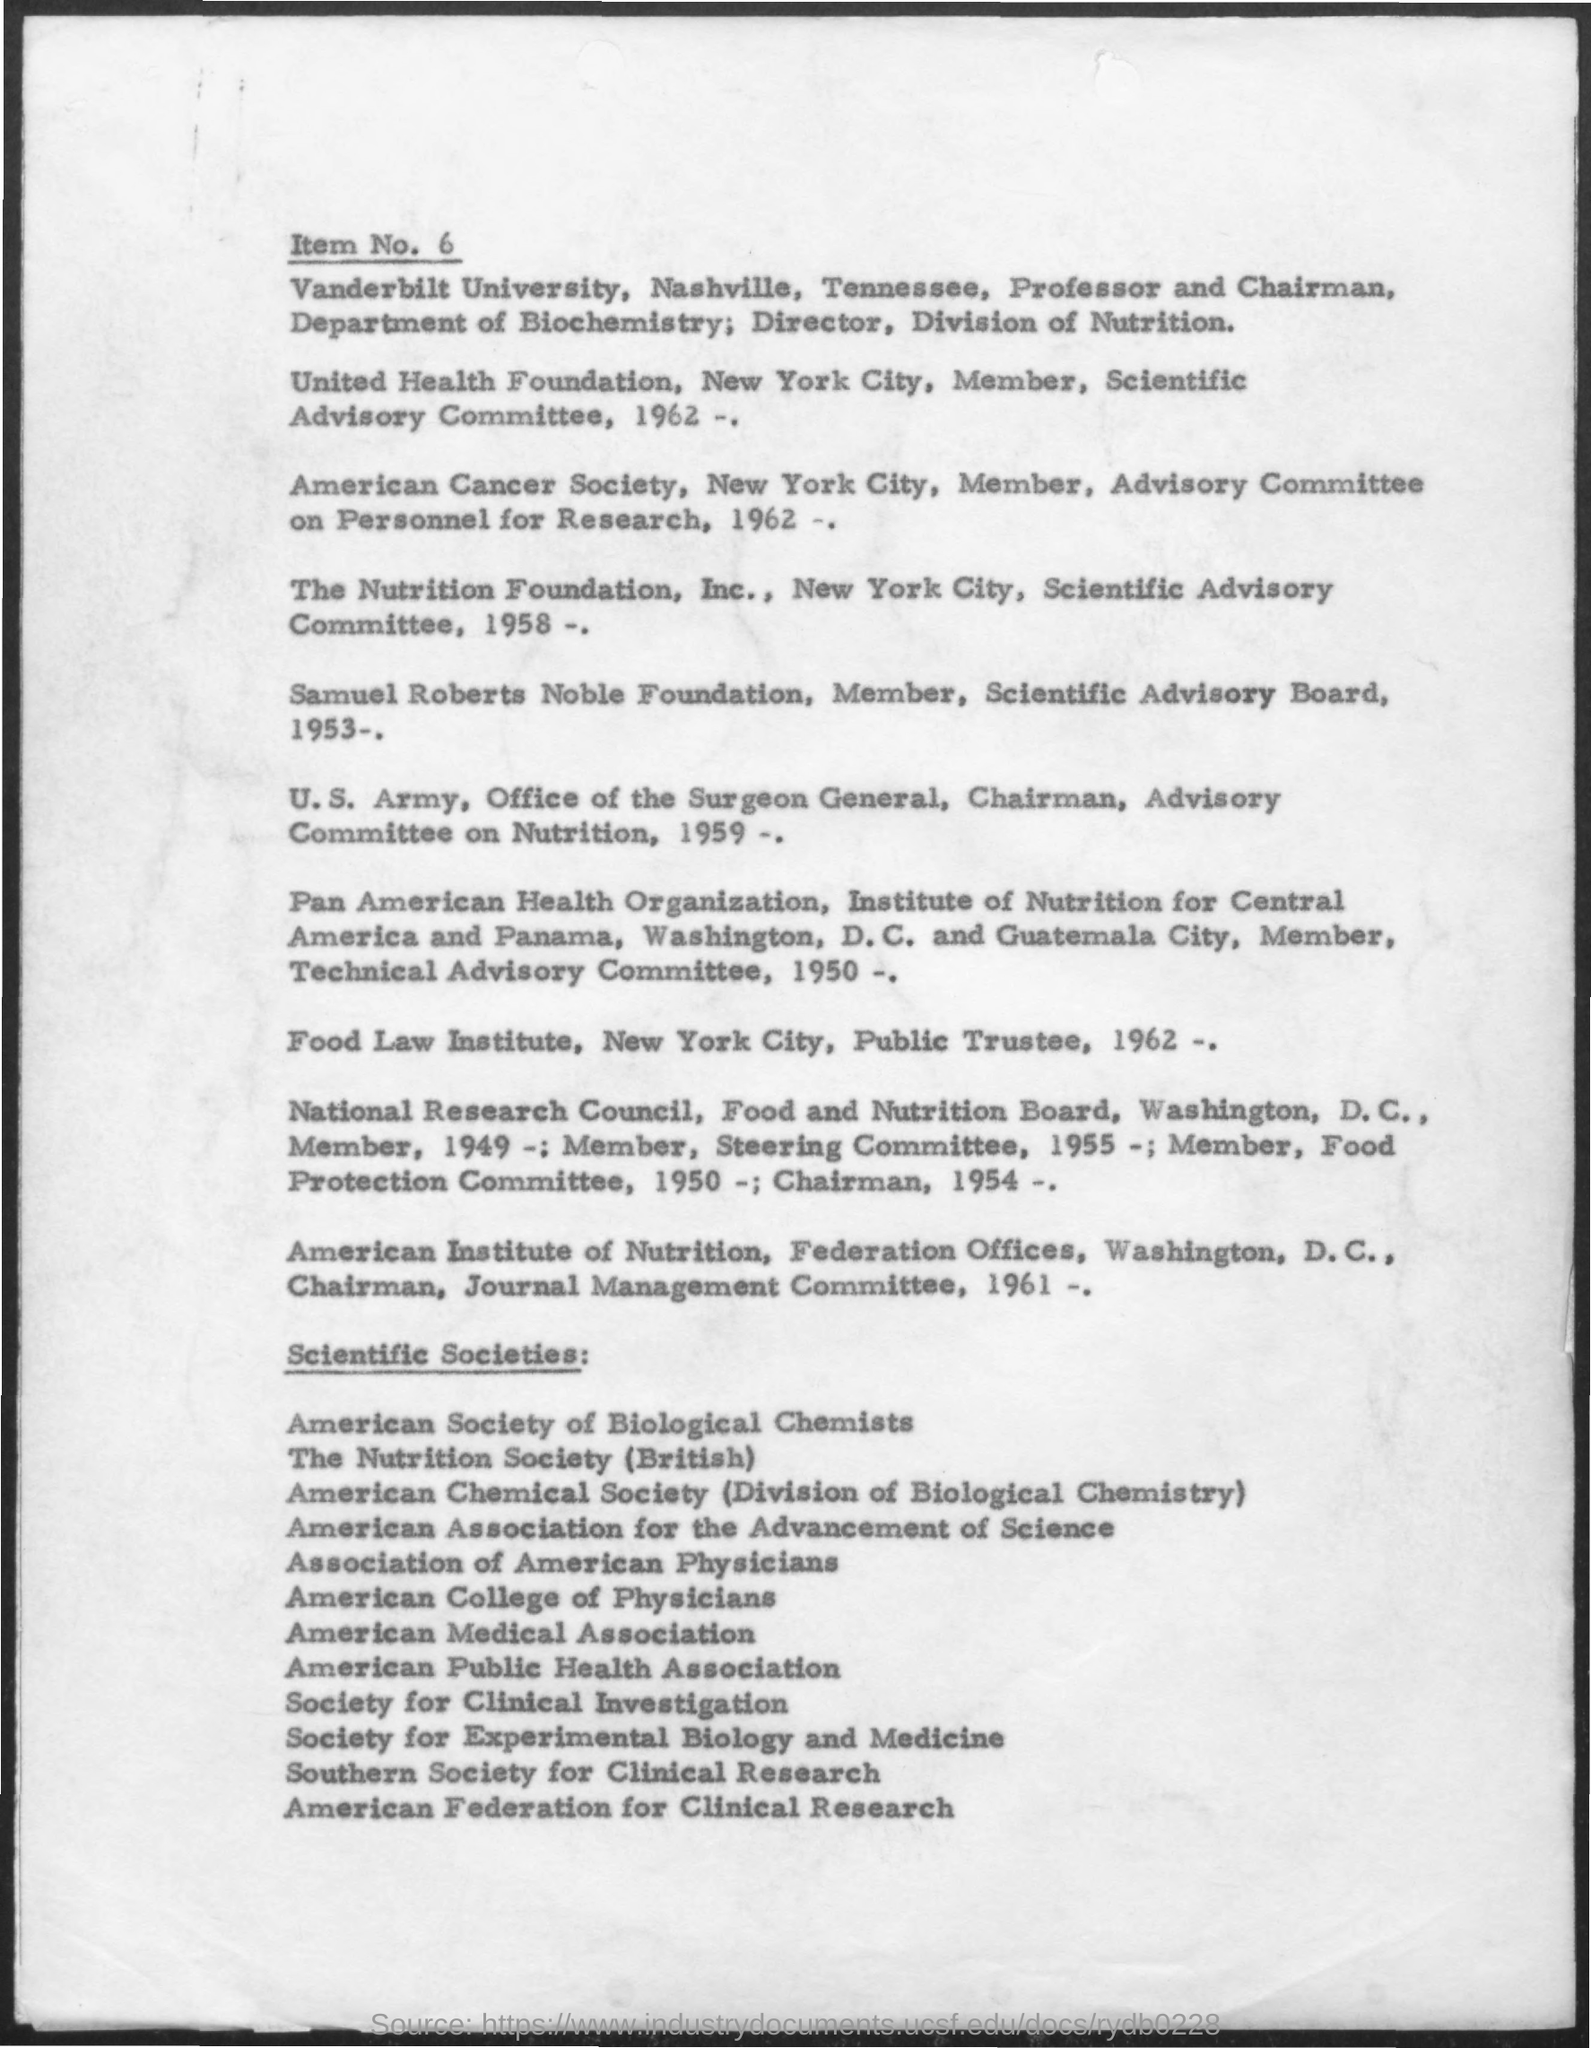Indicate a few pertinent items in this graphic. The item number is 6. The Food Law Institute was established in 1962. The Nutrition Foundation, Inc. was established in the year 1958. 